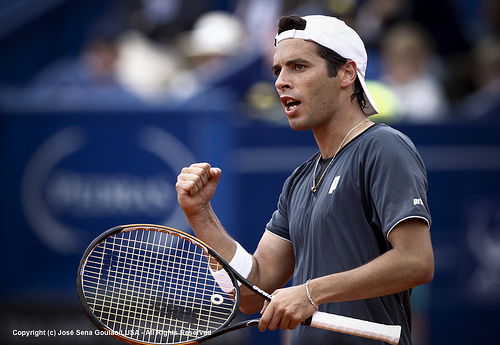Identify the text contained in this image. Copyright c Sona 